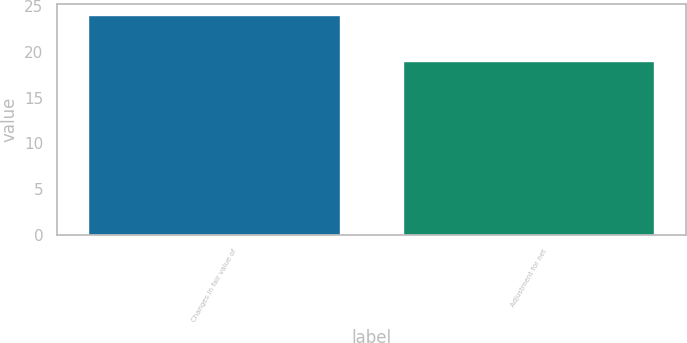<chart> <loc_0><loc_0><loc_500><loc_500><bar_chart><fcel>Changes in fair value of<fcel>Adjustment for net<nl><fcel>24<fcel>19<nl></chart> 